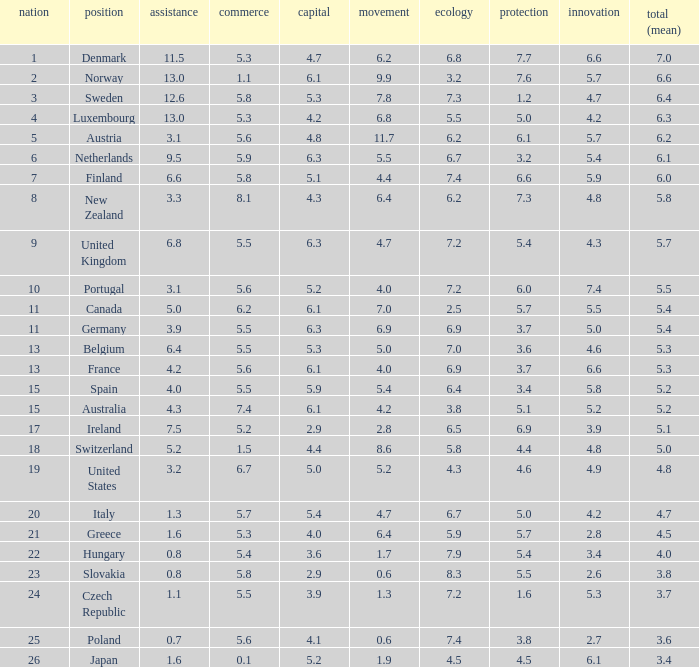What is the environment rating of the country with an overall average rating of 4.7? 6.7. 